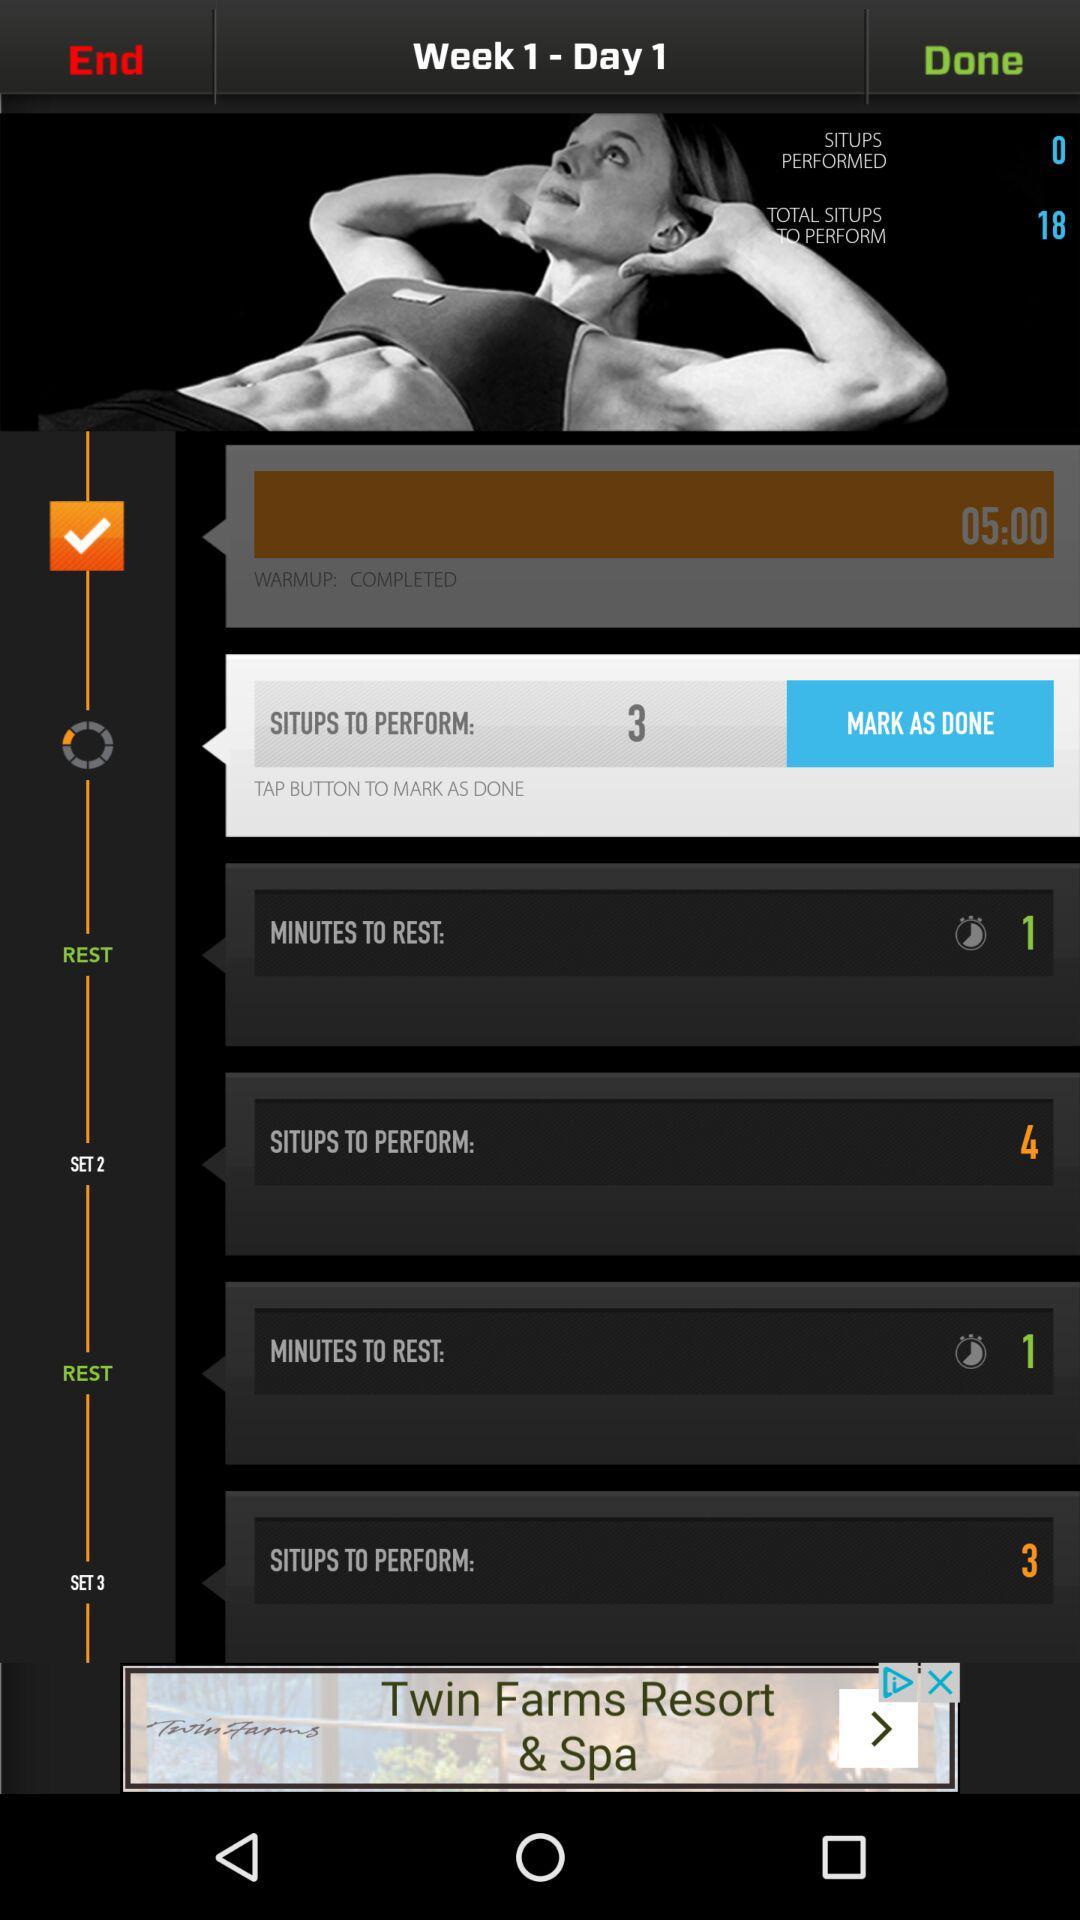How long did it take to warm up? It took 5 minutes to warm up. 